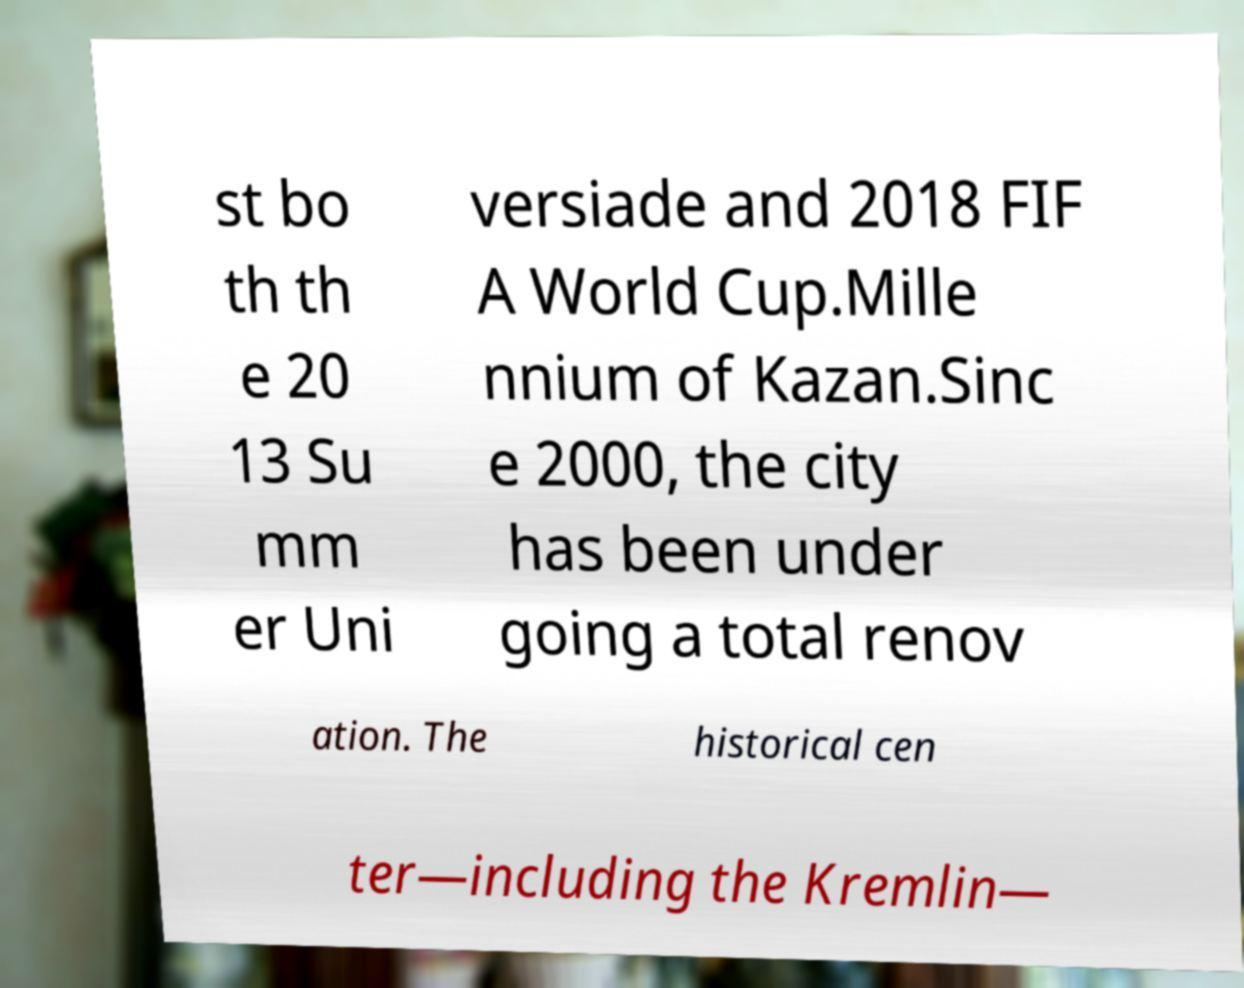Please read and relay the text visible in this image. What does it say? st bo th th e 20 13 Su mm er Uni versiade and 2018 FIF A World Cup.Mille nnium of Kazan.Sinc e 2000, the city has been under going a total renov ation. The historical cen ter—including the Kremlin— 